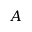Convert formula to latex. <formula><loc_0><loc_0><loc_500><loc_500>A</formula> 